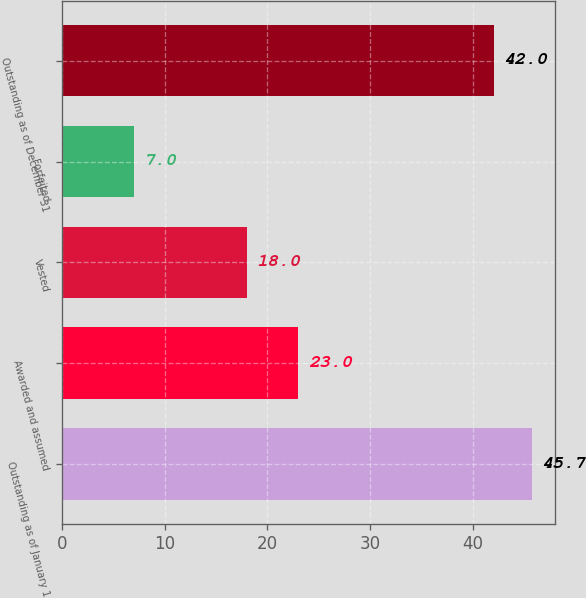Convert chart. <chart><loc_0><loc_0><loc_500><loc_500><bar_chart><fcel>Outstanding as of January 1<fcel>Awarded and assumed<fcel>Vested<fcel>Forfeited<fcel>Outstanding as of December 31<nl><fcel>45.7<fcel>23<fcel>18<fcel>7<fcel>42<nl></chart> 